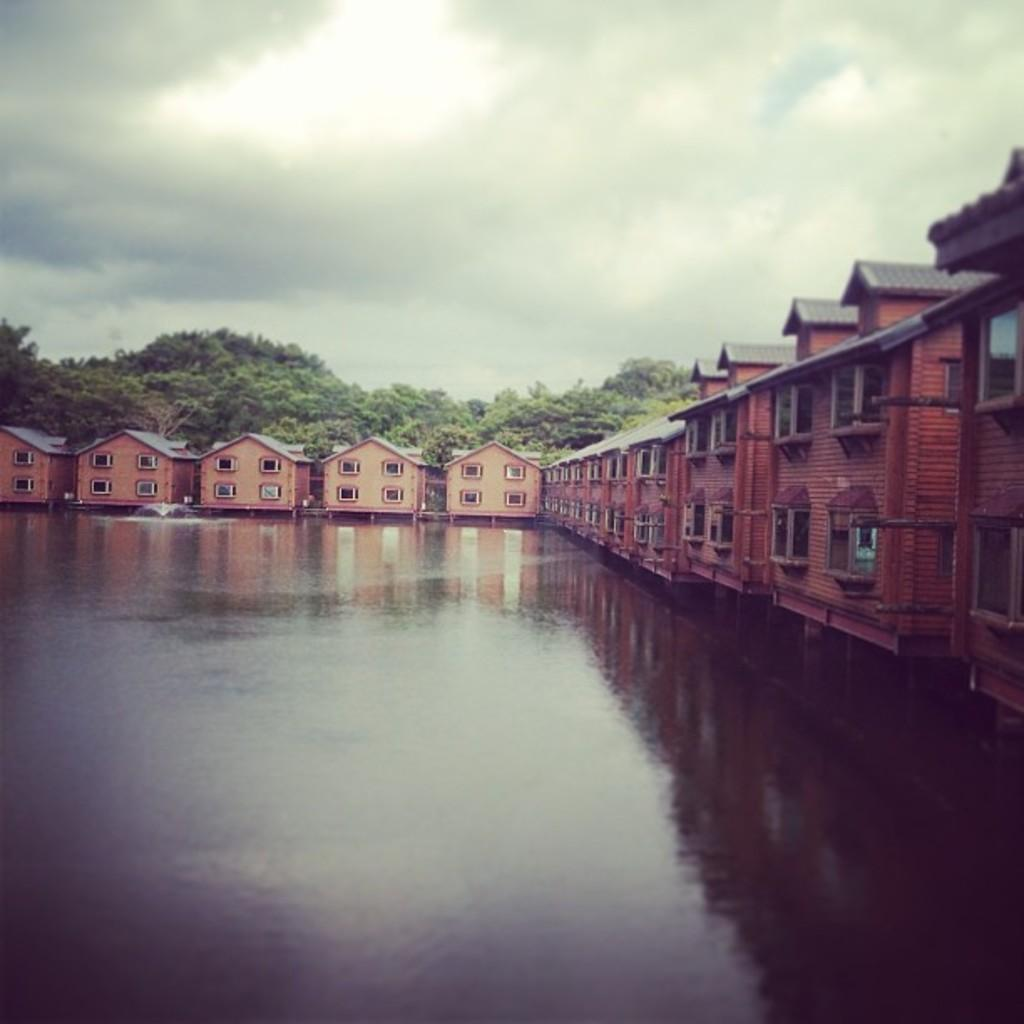What is the primary element visible in the image? There is water visible in the image. What structures are located near the water? There are buildings beside the water. What type of vegetation can be seen in the background of the image? There is a group of trees in the background of the image. What is visible at the top of the image? The sky is visible at the top of the image. How many chickens are present in the image? There are no chickens present in the image. What advice does the mom give in the image? There is no mom or any advice-giving scene in the image. 